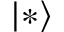Convert formula to latex. <formula><loc_0><loc_0><loc_500><loc_500>| * \rangle</formula> 